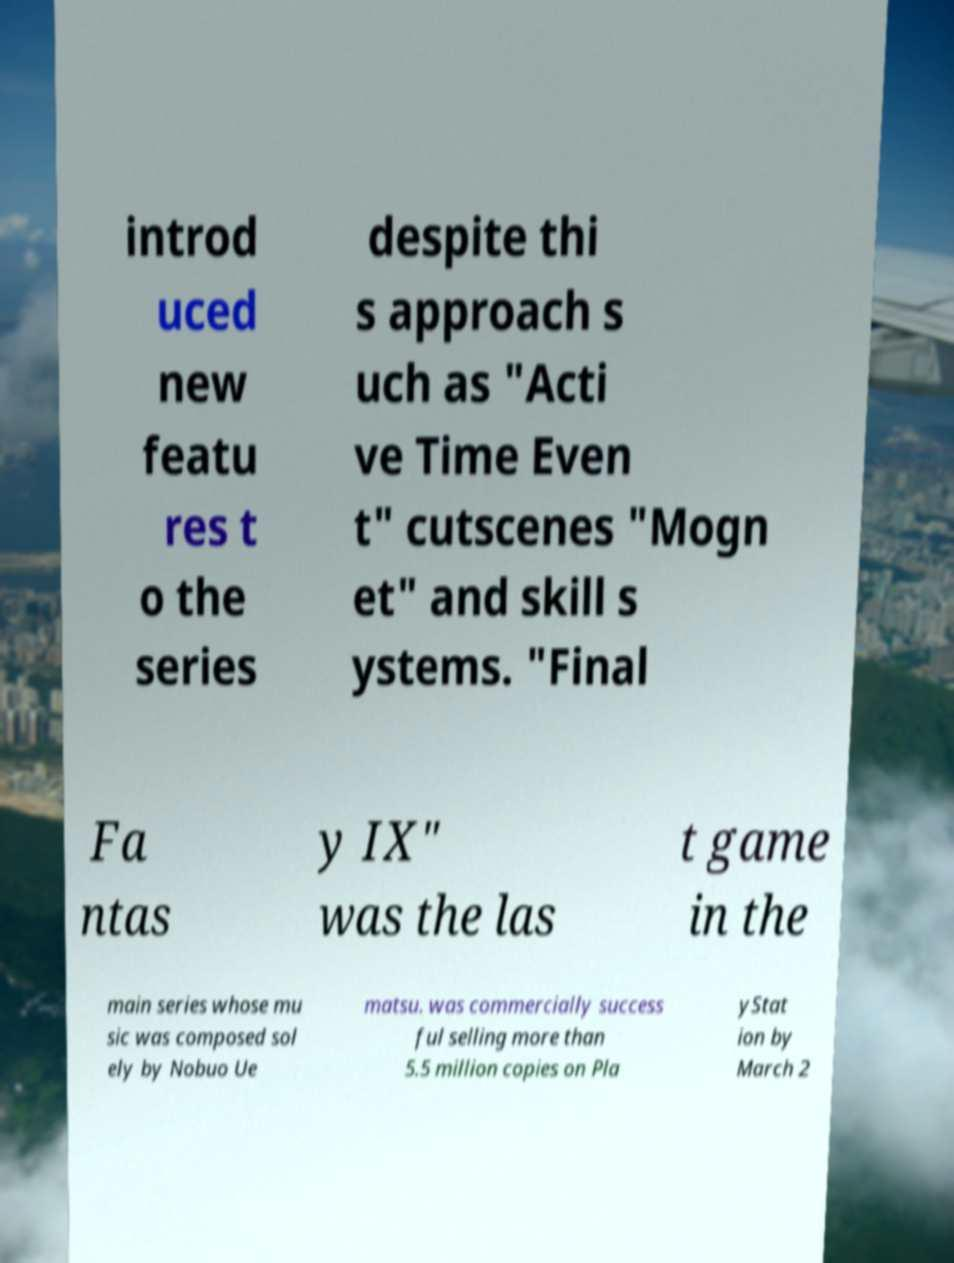I need the written content from this picture converted into text. Can you do that? introd uced new featu res t o the series despite thi s approach s uch as "Acti ve Time Even t" cutscenes "Mogn et" and skill s ystems. "Final Fa ntas y IX" was the las t game in the main series whose mu sic was composed sol ely by Nobuo Ue matsu. was commercially success ful selling more than 5.5 million copies on Pla yStat ion by March 2 